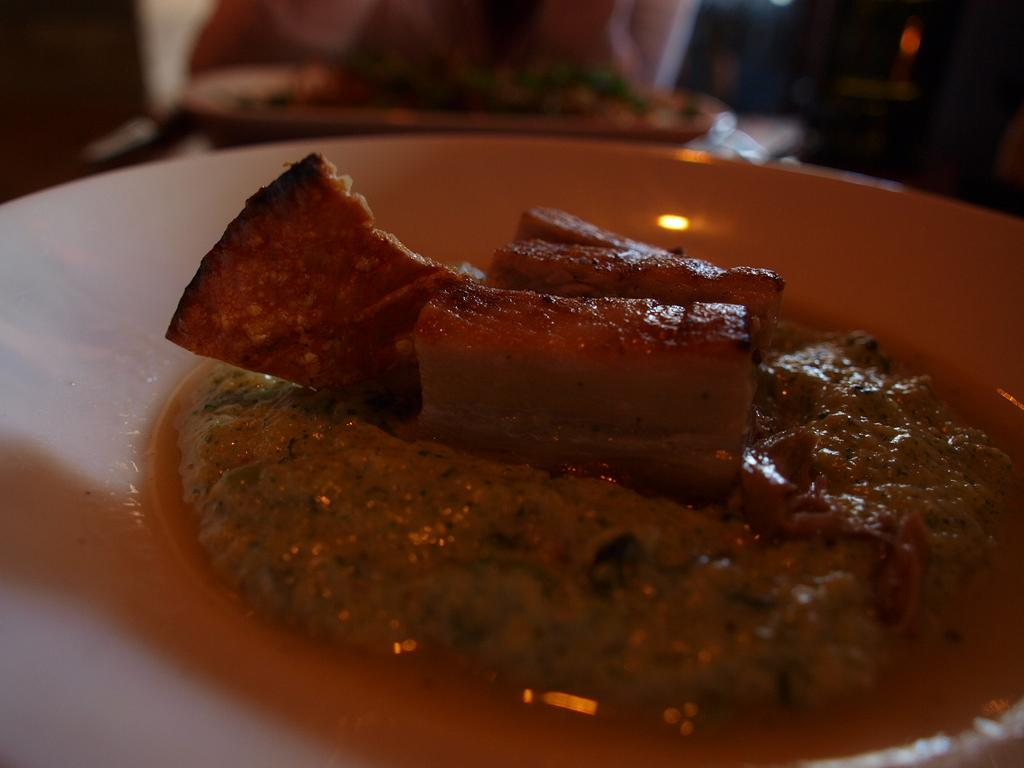What is the main subject in the foreground of the image? There is a platter with food items in the foreground of the image. Can you describe the food items on the platter? Unfortunately, the specific food items cannot be identified from the provided facts. What else can be seen in the image besides the platter with food items? There are other objects visible in the background of the image, but their details are not mentioned in the facts. What does your aunt desire for breakfast in the image? There is no mention of an aunt or breakfast in the provided facts, so it is not possible to answer this question. 